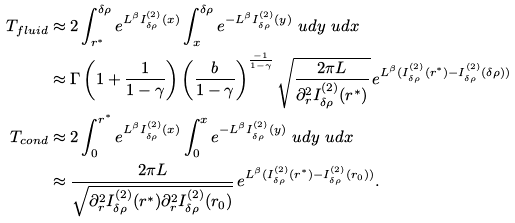<formula> <loc_0><loc_0><loc_500><loc_500>T _ { f l u i d } & \approx 2 \int _ { r ^ { * } } ^ { \delta \rho } e ^ { L ^ { \beta } I _ { \delta \rho } ^ { ( 2 ) } ( x ) } \int _ { x } ^ { \delta \rho } e ^ { - L ^ { \beta } I _ { \delta \rho } ^ { ( 2 ) } ( y ) } \ u d y \ u d x \\ & \approx \Gamma \left ( 1 + \frac { 1 } { 1 - \gamma } \right ) \left ( \frac { b } { 1 - \gamma } \right ) ^ { \frac { - 1 } { 1 - \gamma } } \sqrt { \frac { 2 \pi L } { \partial ^ { 2 } _ { r } I _ { \delta \rho } ^ { ( 2 ) } ( r ^ { * } ) } } \, e ^ { L ^ { \beta } ( I _ { \delta \rho } ^ { ( 2 ) } ( r ^ { * } ) - I _ { \delta \rho } ^ { ( 2 ) } ( \delta \rho ) ) } \\ T _ { c o n d } & \approx 2 \int _ { 0 } ^ { r ^ { * } } e ^ { L ^ { \beta } I _ { \delta \rho } ^ { ( 2 ) } ( x ) } \int _ { 0 } ^ { x } e ^ { - L ^ { \beta } I _ { \delta \rho } ^ { ( 2 ) } ( y ) } \ u d y \ u d x \\ & \approx \frac { 2 \pi L } { \sqrt { \partial ^ { 2 } _ { r } I _ { \delta \rho } ^ { ( 2 ) } ( r ^ { * } ) \partial ^ { 2 } _ { r } I _ { \delta \rho } ^ { ( 2 ) } ( r _ { 0 } ) } } \, e ^ { L ^ { \beta } ( I _ { \delta \rho } ^ { ( 2 ) } ( r ^ { * } ) - I _ { \delta \rho } ^ { ( 2 ) } ( r _ { 0 } ) ) } .</formula> 